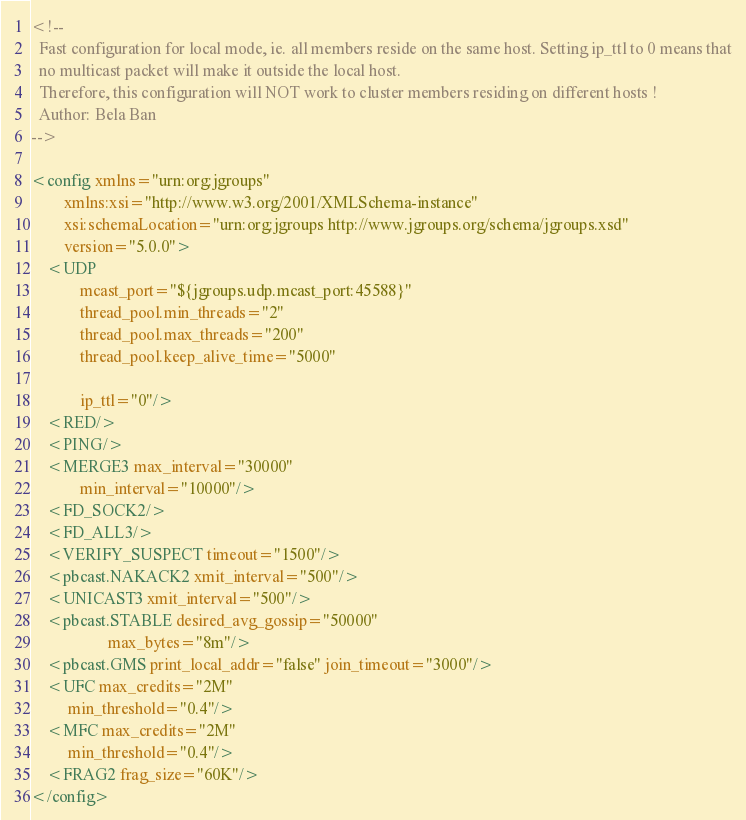Convert code to text. <code><loc_0><loc_0><loc_500><loc_500><_XML_><!--
  Fast configuration for local mode, ie. all members reside on the same host. Setting ip_ttl to 0 means that
  no multicast packet will make it outside the local host.
  Therefore, this configuration will NOT work to cluster members residing on different hosts !
  Author: Bela Ban
-->

<config xmlns="urn:org:jgroups"
		xmlns:xsi="http://www.w3.org/2001/XMLSchema-instance"
		xsi:schemaLocation="urn:org:jgroups http://www.jgroups.org/schema/jgroups.xsd"
		version="5.0.0">
	<UDP
			mcast_port="${jgroups.udp.mcast_port:45588}"
			thread_pool.min_threads="2"
			thread_pool.max_threads="200"
			thread_pool.keep_alive_time="5000"

			ip_ttl="0"/>
	<RED/>
	<PING/>
	<MERGE3 max_interval="30000"
			min_interval="10000"/>
	<FD_SOCK2/>
	<FD_ALL3/>
	<VERIFY_SUSPECT timeout="1500"/>
	<pbcast.NAKACK2 xmit_interval="500"/>
	<UNICAST3 xmit_interval="500"/>
	<pbcast.STABLE desired_avg_gossip="50000"
				   max_bytes="8m"/>
	<pbcast.GMS print_local_addr="false" join_timeout="3000"/>
	<UFC max_credits="2M"
		 min_threshold="0.4"/>
	<MFC max_credits="2M"
		 min_threshold="0.4"/>
	<FRAG2 frag_size="60K"/>
</config></code> 